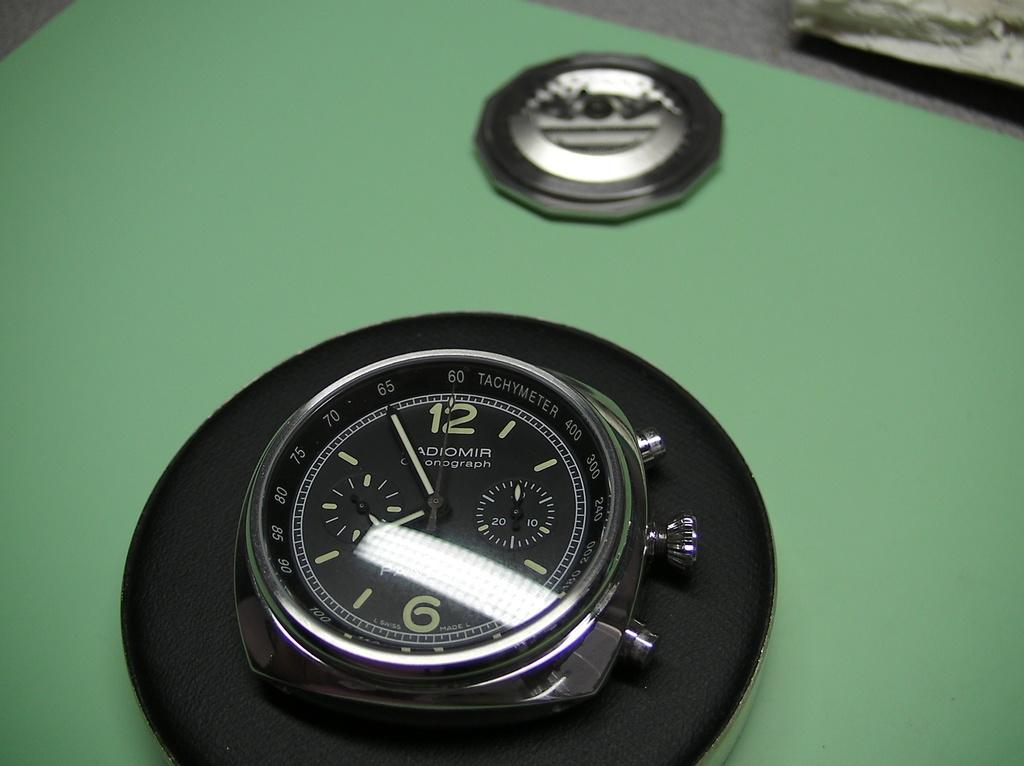<image>
Summarize the visual content of the image. Black face of a clock which says Adiomir on the face. 